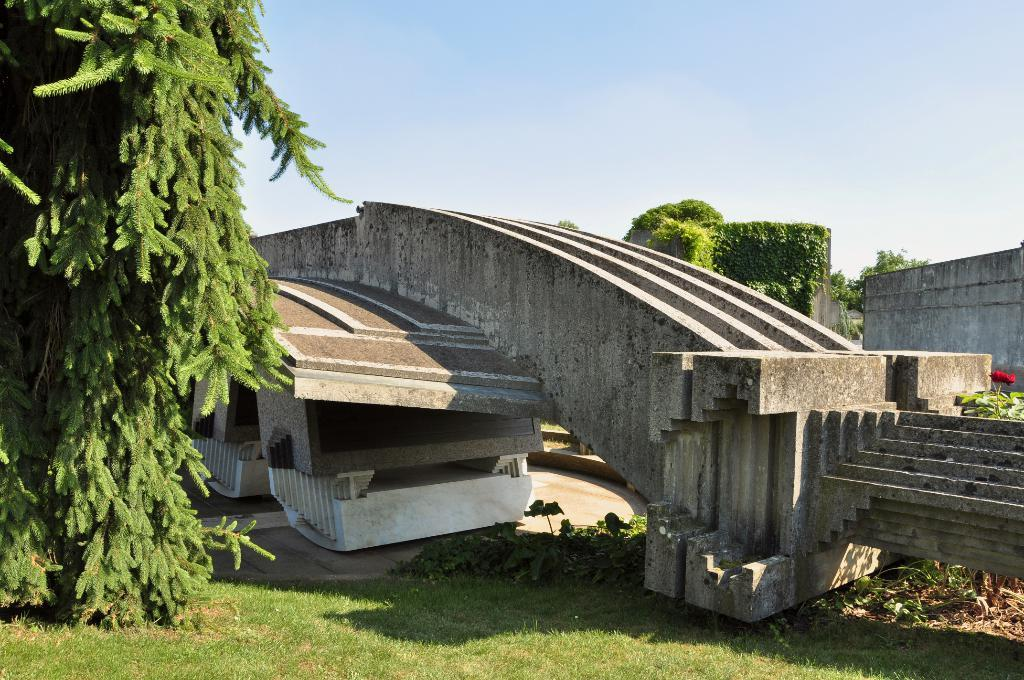What type of structure is present in the image? There is a concrete bridge in the image. What type of vegetation can be seen in the image? There is grass and plants in the image. What part of the natural environment is visible in the image? The ground is visible in the image. What else can be seen in the image besides the bridge and vegetation? There is a wall in the image. What is visible in the background of the image? The sky is visible in the image. What is the condition of the mouth in the image? There is no mouth present in the image. How many minutes does it take for the plants to grow in the image? The image does not show the plants growing, so it is impossible to determine how long it takes for them to grow. 